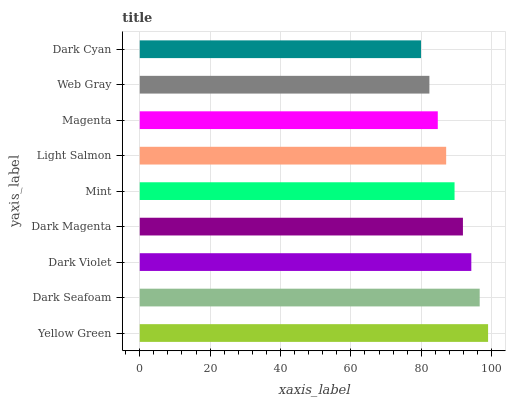Is Dark Cyan the minimum?
Answer yes or no. Yes. Is Yellow Green the maximum?
Answer yes or no. Yes. Is Dark Seafoam the minimum?
Answer yes or no. No. Is Dark Seafoam the maximum?
Answer yes or no. No. Is Yellow Green greater than Dark Seafoam?
Answer yes or no. Yes. Is Dark Seafoam less than Yellow Green?
Answer yes or no. Yes. Is Dark Seafoam greater than Yellow Green?
Answer yes or no. No. Is Yellow Green less than Dark Seafoam?
Answer yes or no. No. Is Mint the high median?
Answer yes or no. Yes. Is Mint the low median?
Answer yes or no. Yes. Is Dark Seafoam the high median?
Answer yes or no. No. Is Dark Seafoam the low median?
Answer yes or no. No. 